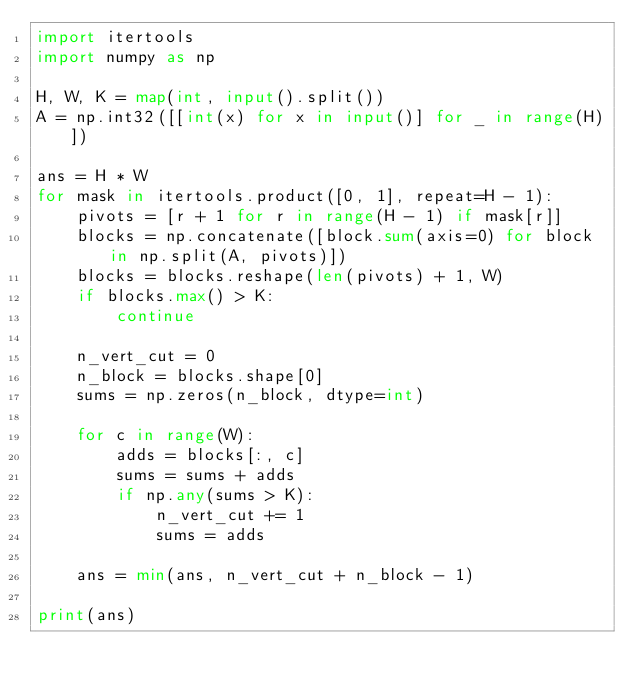<code> <loc_0><loc_0><loc_500><loc_500><_Python_>import itertools
import numpy as np

H, W, K = map(int, input().split())
A = np.int32([[int(x) for x in input()] for _ in range(H)])

ans = H * W
for mask in itertools.product([0, 1], repeat=H - 1):
    pivots = [r + 1 for r in range(H - 1) if mask[r]]
    blocks = np.concatenate([block.sum(axis=0) for block in np.split(A, pivots)])
    blocks = blocks.reshape(len(pivots) + 1, W)
    if blocks.max() > K:
        continue

    n_vert_cut = 0
    n_block = blocks.shape[0]
    sums = np.zeros(n_block, dtype=int)

    for c in range(W):
        adds = blocks[:, c]
        sums = sums + adds
        if np.any(sums > K):
            n_vert_cut += 1
            sums = adds

    ans = min(ans, n_vert_cut + n_block - 1)

print(ans)
</code> 